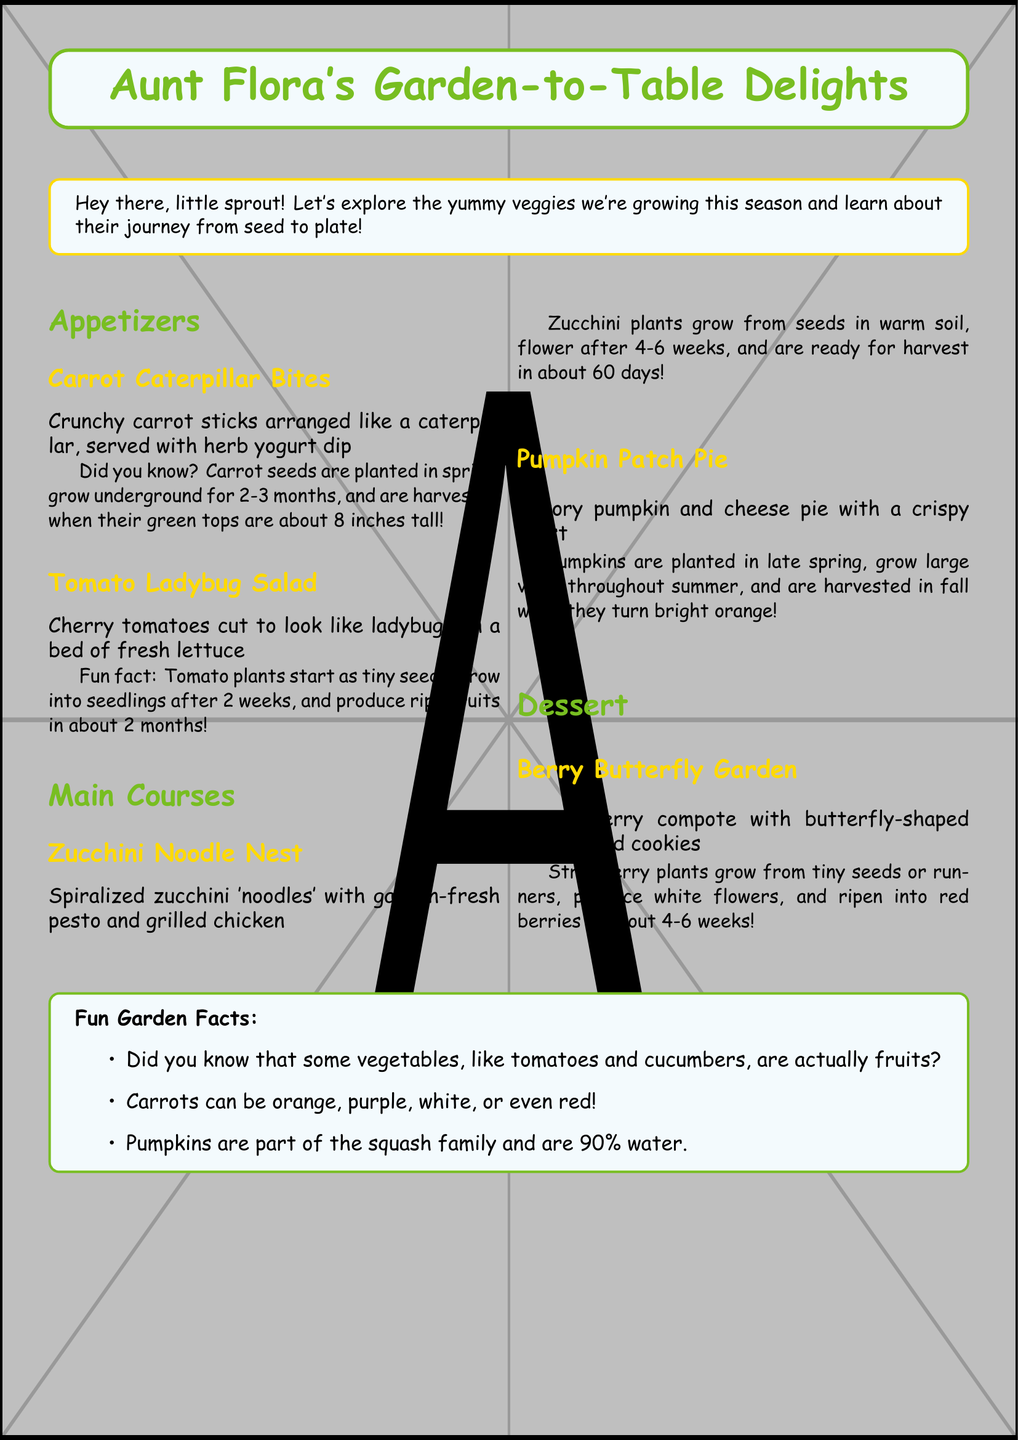What is the name of the appetizer with carrot sticks? The document specifically mentions "Carrot Caterpillar Bites" as the appetizer featuring carrot sticks.
Answer: Carrot Caterpillar Bites How long do carrot seeds take to grow underground? The document states that carrot seeds grow underground for 2-3 months before they are harvested.
Answer: 2-3 months What vegetable is used in the Zucchini Noodle Nest? The menu lists zucchini as the primary vegetable in the Zucchini Noodle Nest dish.
Answer: Zucchini How many days does it take for a tomato plant to produce ripe fruits? According to the fun fact, tomato plants produce ripe fruits in about 2 months.
Answer: 2 months What type of dessert is included in the menu? The document specifies the dessert as "Berry Butterfly Garden."
Answer: Berry Butterfly Garden Which vegetables can be orange, purple, white, or red? The document mentions carrots can come in various colors, indicating they are not just orange.
Answer: Carrots What type of dish is "Pumpkin Patch Pie"? The menu describes "Pumpkin Patch Pie" as a savory pie, defining its category.
Answer: Savory pie How long does it take for strawberry plants to ripen into red berries? The document states that strawberries ripen in about 4-6 weeks.
Answer: 4-6 weeks 